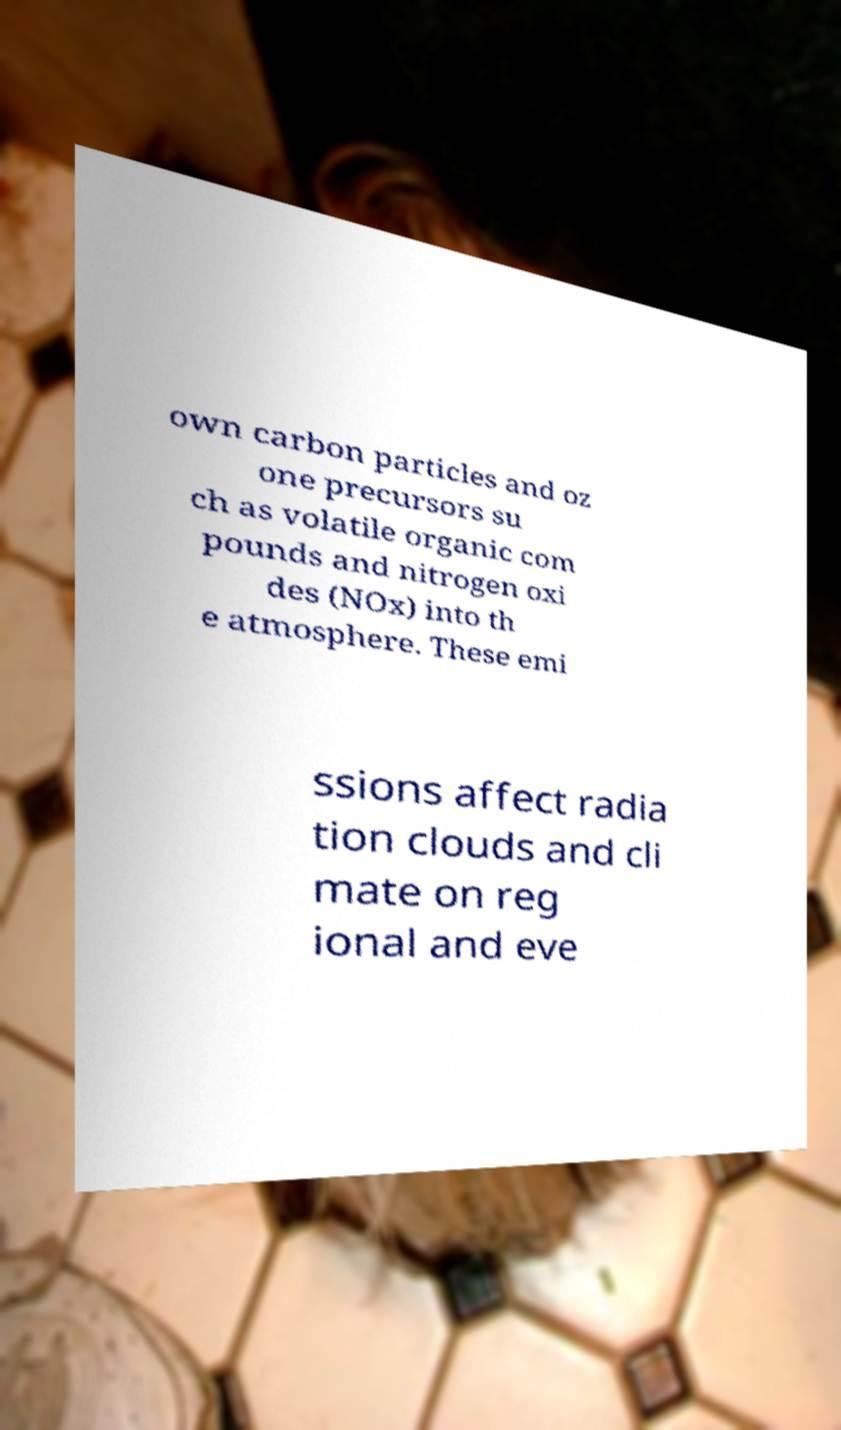Can you read and provide the text displayed in the image?This photo seems to have some interesting text. Can you extract and type it out for me? own carbon particles and oz one precursors su ch as volatile organic com pounds and nitrogen oxi des (NOx) into th e atmosphere. These emi ssions affect radia tion clouds and cli mate on reg ional and eve 